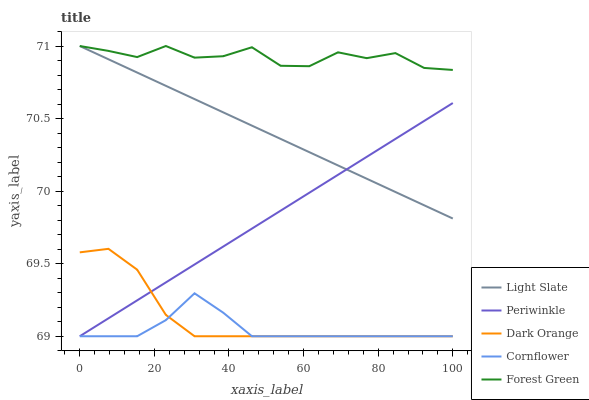Does Cornflower have the minimum area under the curve?
Answer yes or no. Yes. Does Forest Green have the maximum area under the curve?
Answer yes or no. Yes. Does Dark Orange have the minimum area under the curve?
Answer yes or no. No. Does Dark Orange have the maximum area under the curve?
Answer yes or no. No. Is Periwinkle the smoothest?
Answer yes or no. Yes. Is Forest Green the roughest?
Answer yes or no. Yes. Is Dark Orange the smoothest?
Answer yes or no. No. Is Dark Orange the roughest?
Answer yes or no. No. Does Dark Orange have the lowest value?
Answer yes or no. Yes. Does Forest Green have the lowest value?
Answer yes or no. No. Does Forest Green have the highest value?
Answer yes or no. Yes. Does Dark Orange have the highest value?
Answer yes or no. No. Is Cornflower less than Forest Green?
Answer yes or no. Yes. Is Forest Green greater than Dark Orange?
Answer yes or no. Yes. Does Cornflower intersect Dark Orange?
Answer yes or no. Yes. Is Cornflower less than Dark Orange?
Answer yes or no. No. Is Cornflower greater than Dark Orange?
Answer yes or no. No. Does Cornflower intersect Forest Green?
Answer yes or no. No. 